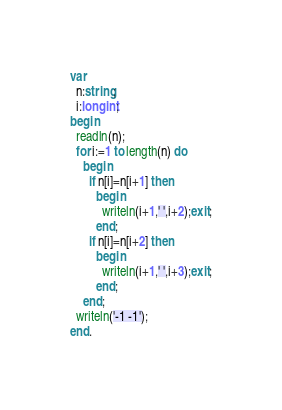Convert code to text. <code><loc_0><loc_0><loc_500><loc_500><_Pascal_>var
  n:string;
  i:longint;
begin
  readln(n);
  for i:=1 to length(n) do
    begin
      if n[i]=n[i+1] then
        begin
          writeln(i+1,' ',i+2);exit;
        end;
      if n[i]=n[i+2] then
        begin
          writeln(i+1,' ',i+3);exit;
        end;
    end;
  writeln('-1 -1');
end.</code> 